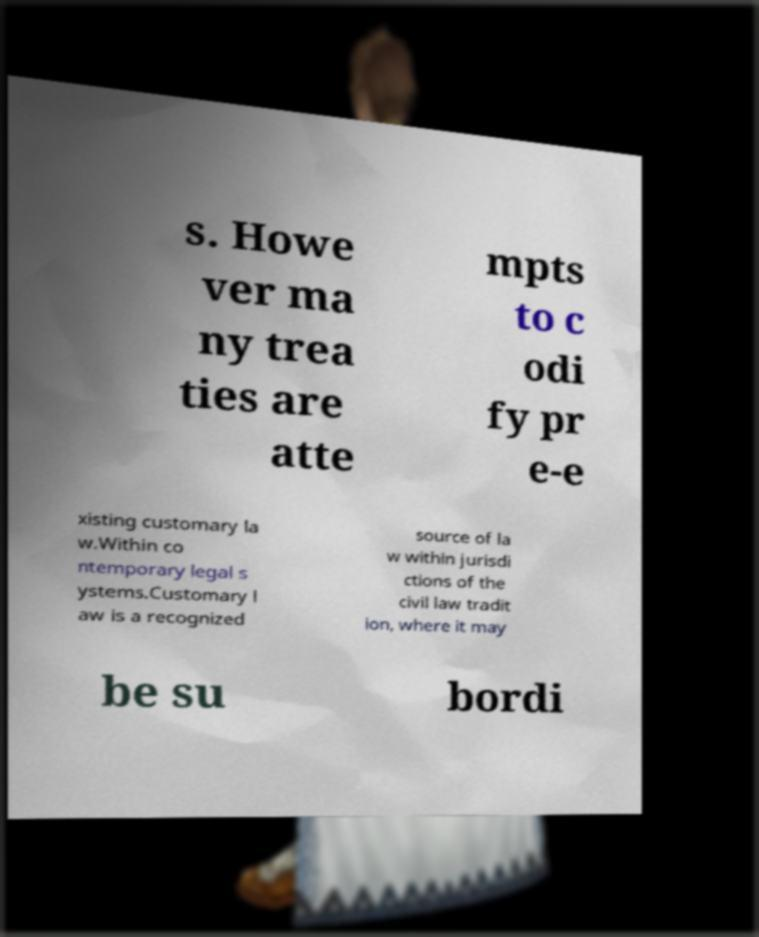Could you extract and type out the text from this image? s. Howe ver ma ny trea ties are atte mpts to c odi fy pr e-e xisting customary la w.Within co ntemporary legal s ystems.Customary l aw is a recognized source of la w within jurisdi ctions of the civil law tradit ion, where it may be su bordi 